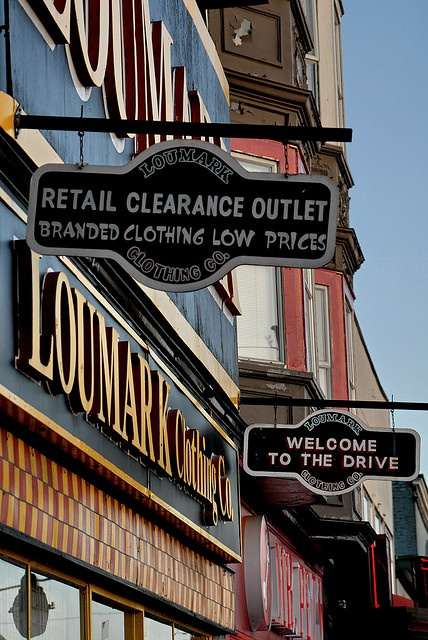Describe the objects in this image and their specific colors. I can see various objects in this image with different colors. 